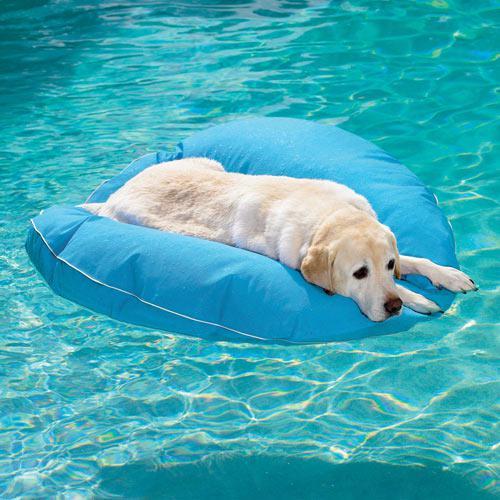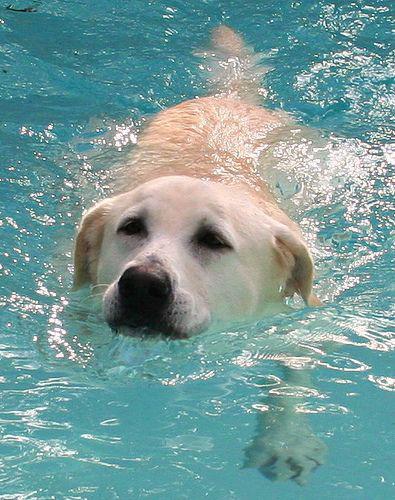The first image is the image on the left, the second image is the image on the right. For the images displayed, is the sentence "Each image shows a blond labrador retriever in the blue water of a swimming pool, and at least one dog is swimming forward." factually correct? Answer yes or no. Yes. 